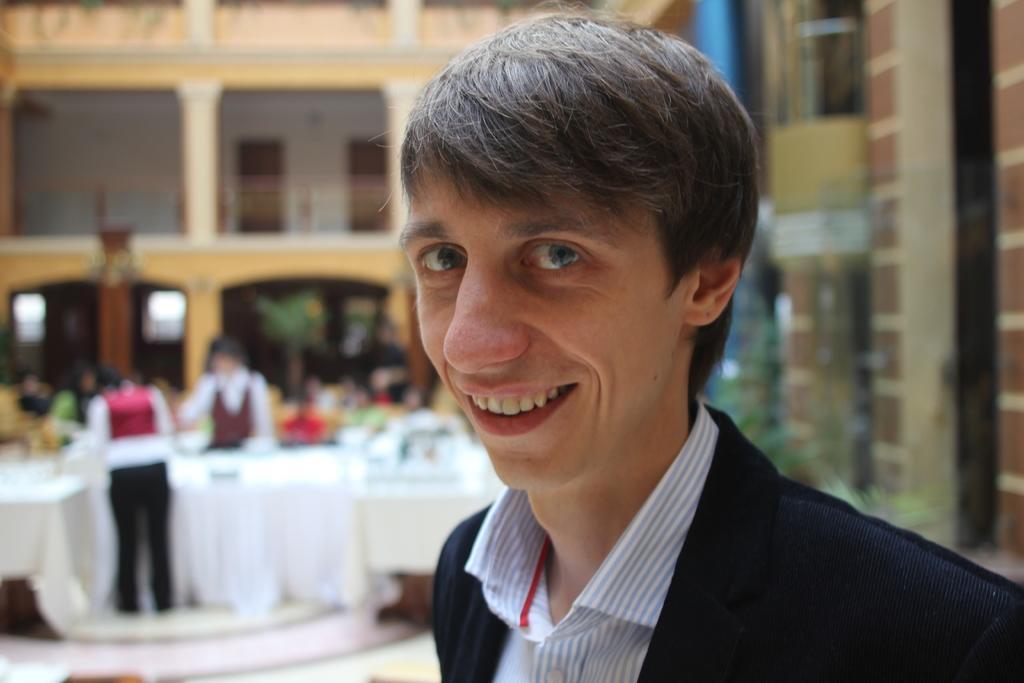How would you summarize this image in a sentence or two? In this picture we can see group of people, on the right side of the image we can see a person and the person is smiling, in the background we can find few tables and plants. 